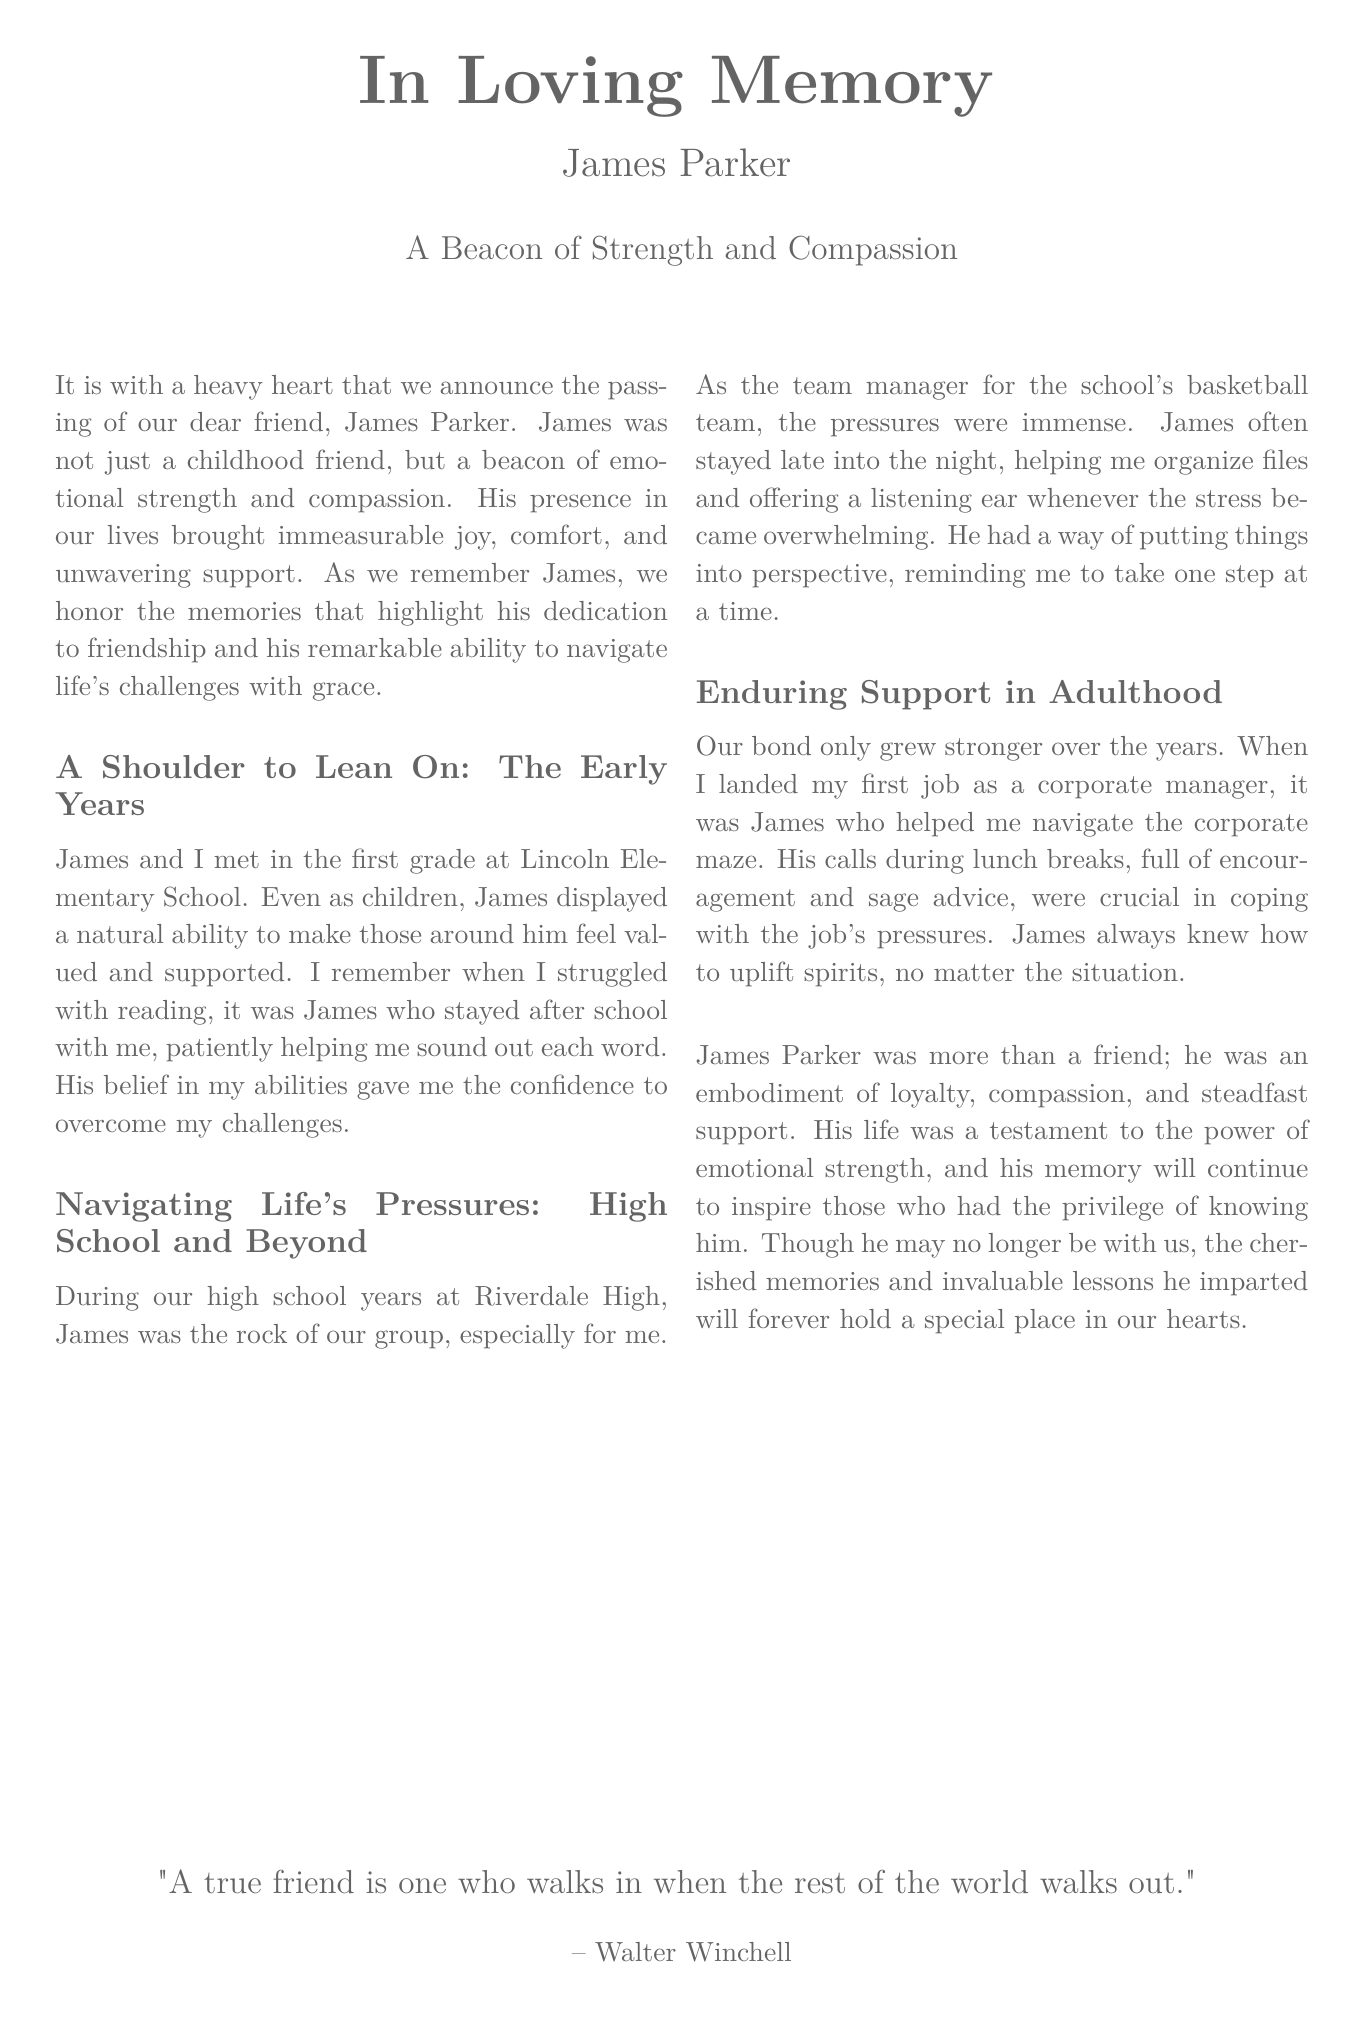What is the full name of the person being remembered? The full name of the person being remembered is mentioned in the title section of the document.
Answer: James Parker What relationship did the narrator have with James Parker? The narrator describes their relationship with James, which is characterized as a close friendship since childhood.
Answer: Childhood friend At which school did James and the narrator meet? The document specifies the school where they first met.
Answer: Lincoln Elementary School What profession did James help the narrator with during adulthood? The document states the profession the narrator was starting and mentions James's support during that time.
Answer: Corporate manager What was James's role in high school? The document identifies James's involvement in a specific school activity during their high school years.
Answer: Team manager Which quote is included at the end of the document? The document concludes with a quote attributed to a well-known figure.
Answer: "A true friend is one who walks in when the rest of the world walks out." How did James help the narrator with reading in elementary school? The document details how James supported the narrator during a specific learning challenge.
Answer: Patiently helping with reading What character traits are highlighted about James in the obituary? The document describes qualities that define James's character throughout his life, especially in relation to others.
Answer: Loyalty, compassion, steadfast support What emotional impact did James have on the narrator? The document discusses the effect James had on the narrator's emotional state during tough times.
Answer: Uplift spirits 